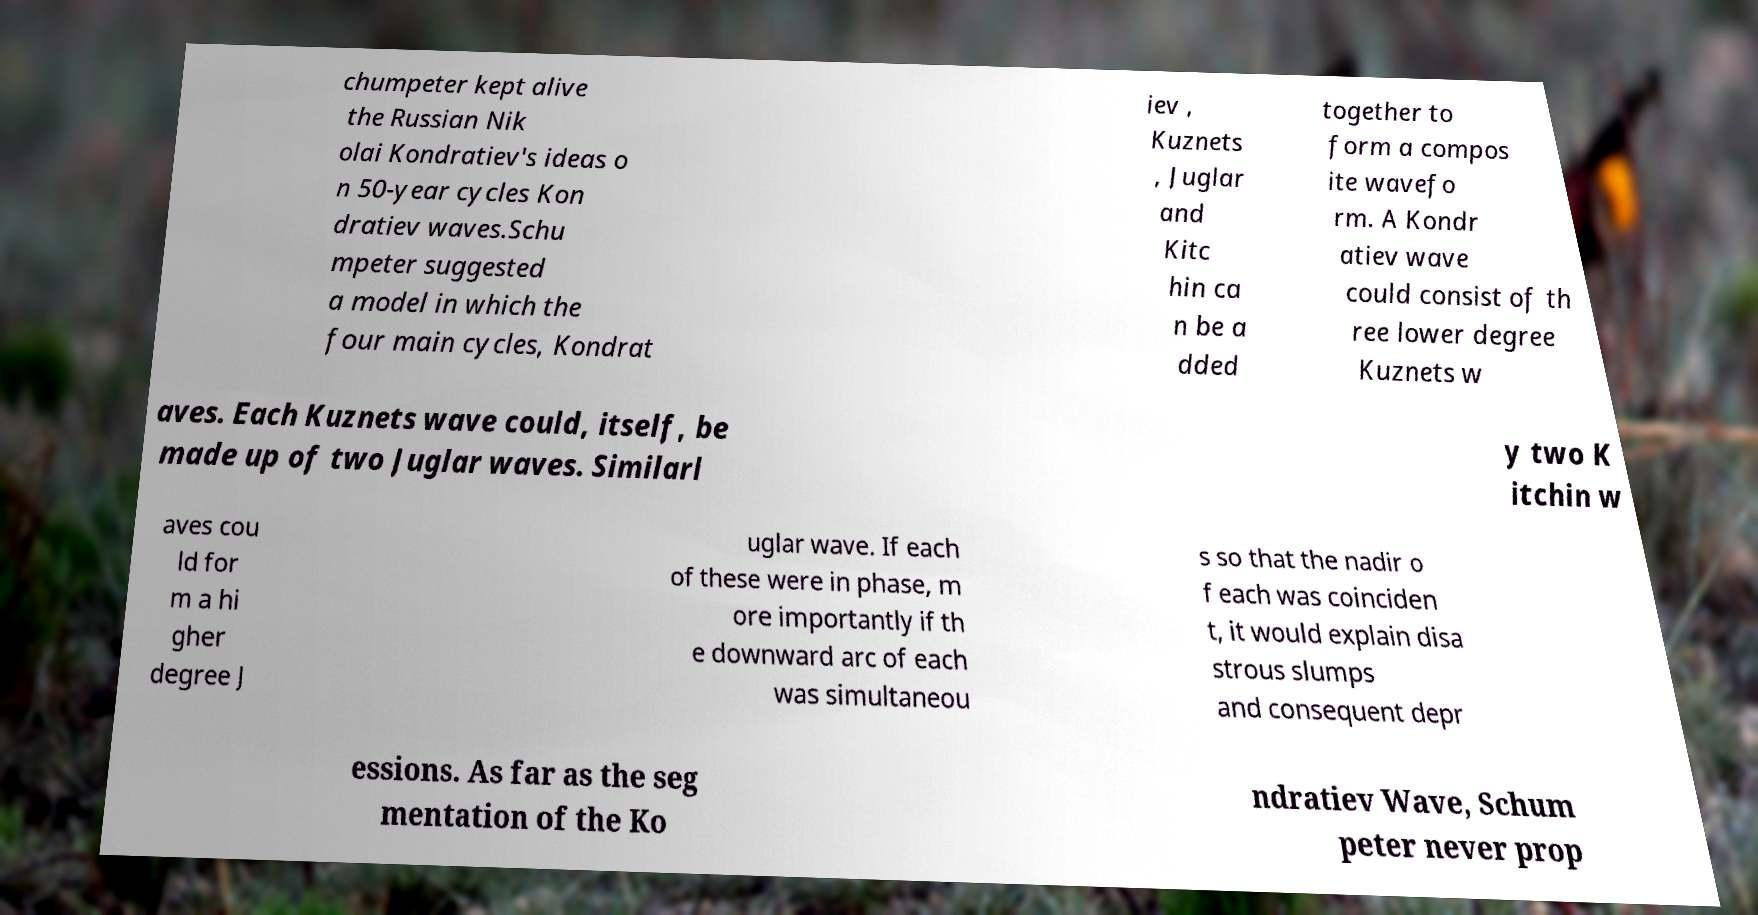There's text embedded in this image that I need extracted. Can you transcribe it verbatim? chumpeter kept alive the Russian Nik olai Kondratiev's ideas o n 50-year cycles Kon dratiev waves.Schu mpeter suggested a model in which the four main cycles, Kondrat iev , Kuznets , Juglar and Kitc hin ca n be a dded together to form a compos ite wavefo rm. A Kondr atiev wave could consist of th ree lower degree Kuznets w aves. Each Kuznets wave could, itself, be made up of two Juglar waves. Similarl y two K itchin w aves cou ld for m a hi gher degree J uglar wave. If each of these were in phase, m ore importantly if th e downward arc of each was simultaneou s so that the nadir o f each was coinciden t, it would explain disa strous slumps and consequent depr essions. As far as the seg mentation of the Ko ndratiev Wave, Schum peter never prop 